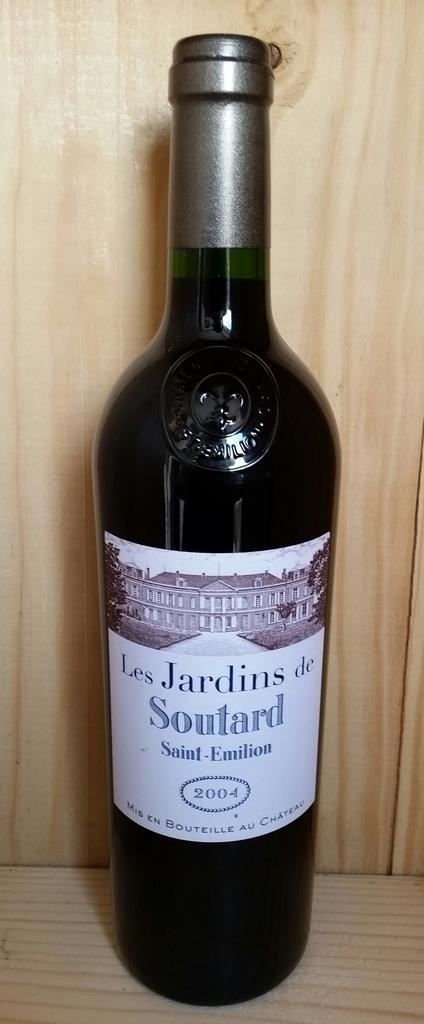<image>
Share a concise interpretation of the image provided. A bottle of Les Jardins Soutard wine is displayed against a wooden backdrop. 